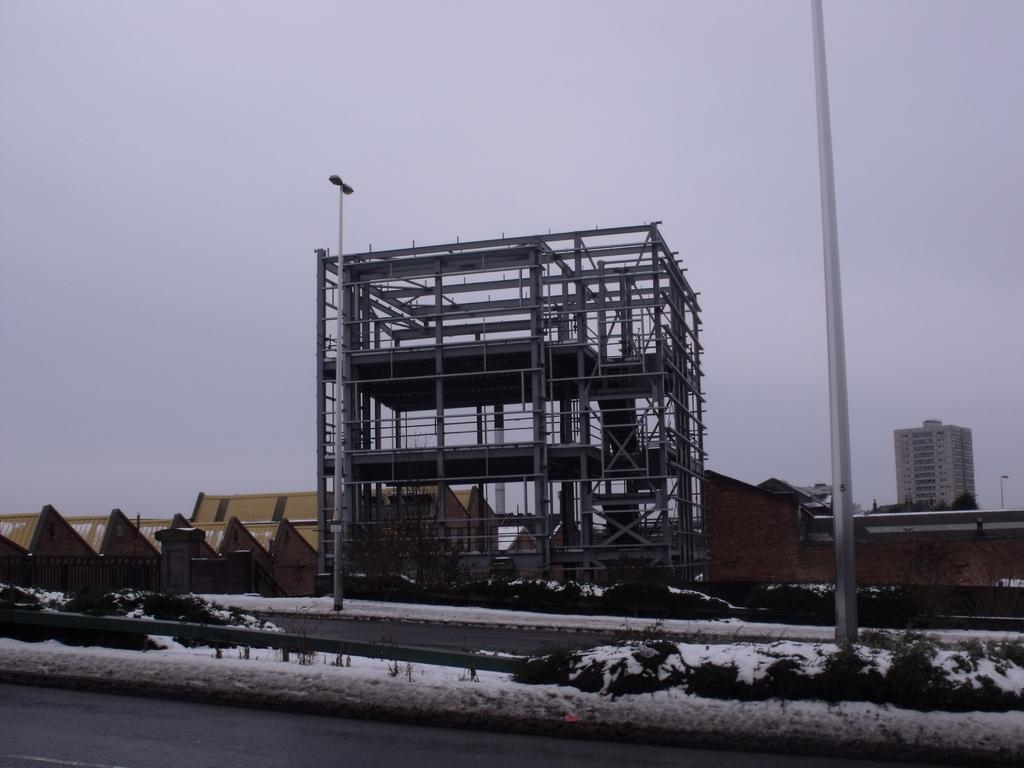Please provide a concise description of this image. In this image there is a road and under construction building, beside that there are some pyramid shaped buildings. 